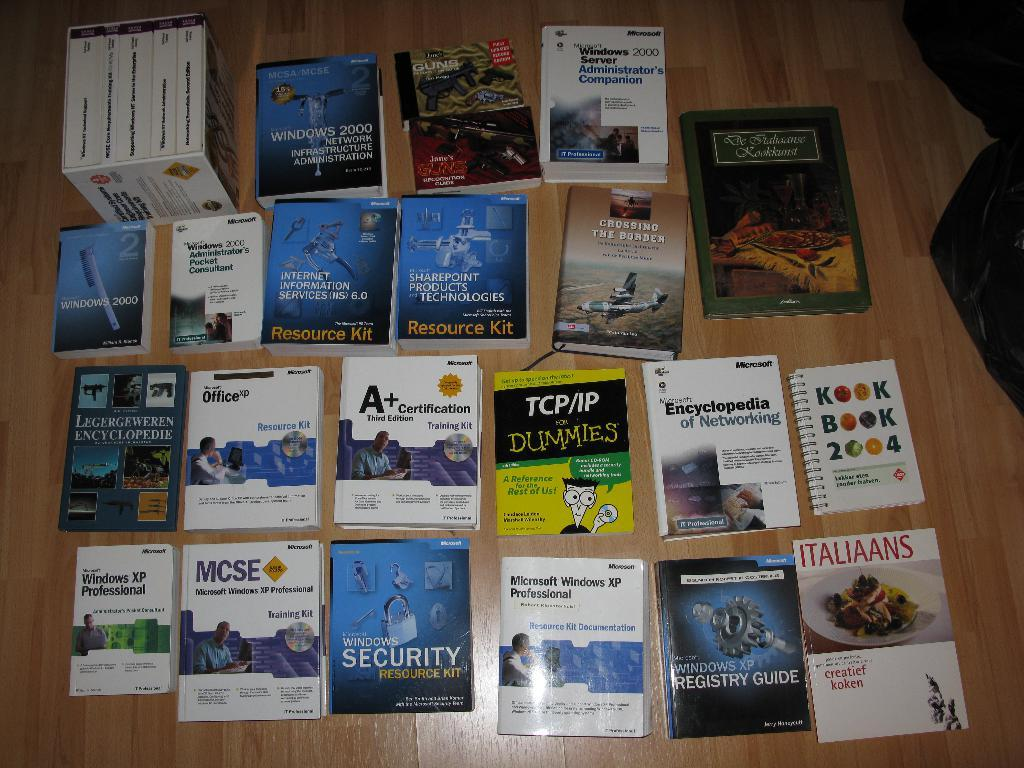Provide a one-sentence caption for the provided image. A spread of books including TCP/IP for Dummies. 